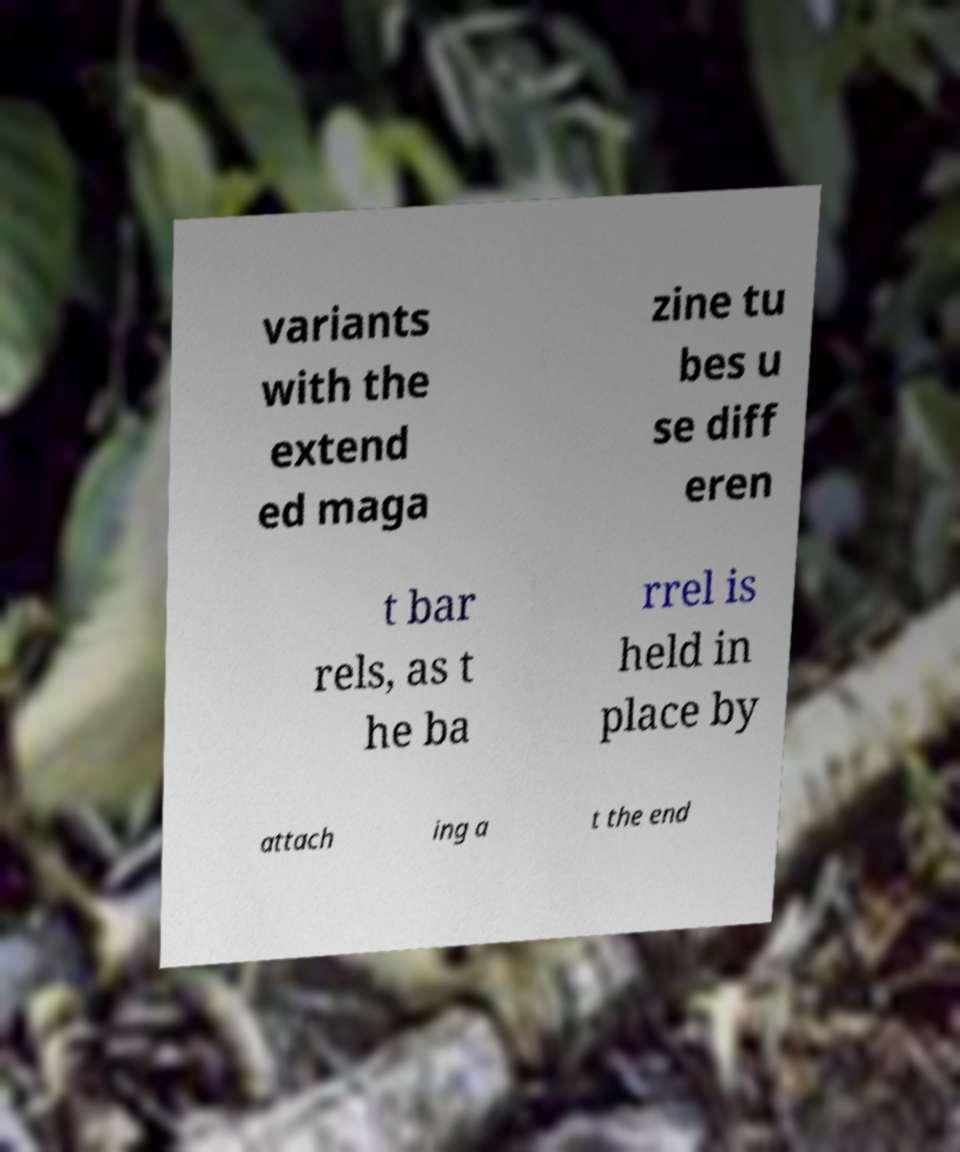Can you accurately transcribe the text from the provided image for me? variants with the extend ed maga zine tu bes u se diff eren t bar rels, as t he ba rrel is held in place by attach ing a t the end 